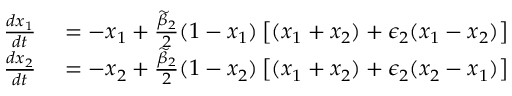<formula> <loc_0><loc_0><loc_500><loc_500>\begin{array} { r l } { \frac { d x _ { 1 } } { d t } } & = - x _ { 1 } + \frac { \widetilde { \beta } _ { 2 } } { 2 } ( 1 - x _ { 1 } ) \left [ ( x _ { 1 } + x _ { 2 } ) + \epsilon _ { 2 } ( x _ { 1 } - x _ { 2 } ) \right ] } \\ { \frac { d x _ { 2 } } { d t } } & = - x _ { 2 } + \frac { \widetilde { \beta } _ { 2 } } { 2 } ( 1 - x _ { 2 } ) \left [ ( x _ { 1 } + x _ { 2 } ) + \epsilon _ { 2 } ( x _ { 2 } - x _ { 1 } ) \right ] } \end{array}</formula> 